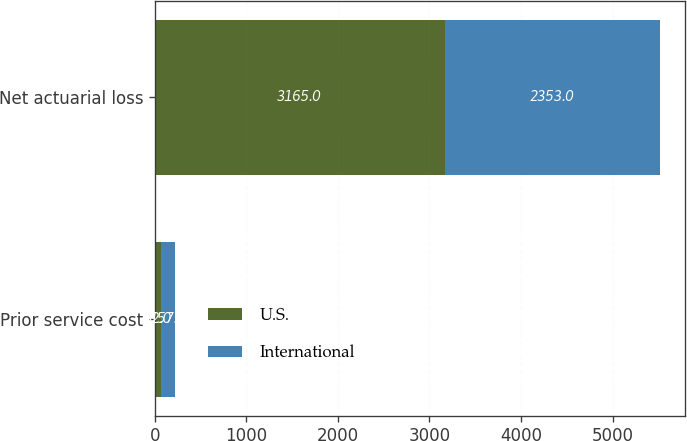Convert chart to OTSL. <chart><loc_0><loc_0><loc_500><loc_500><stacked_bar_chart><ecel><fcel>Prior service cost<fcel>Net actuarial loss<nl><fcel>U.S.<fcel>62<fcel>3165<nl><fcel>International<fcel>157<fcel>2353<nl></chart> 